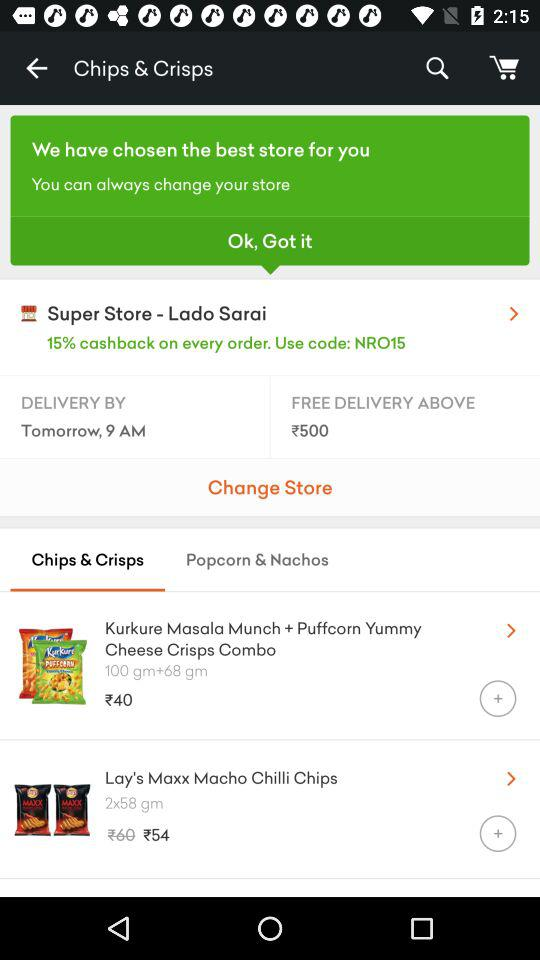What is the given store location? The given store location is Lado Sarai. 